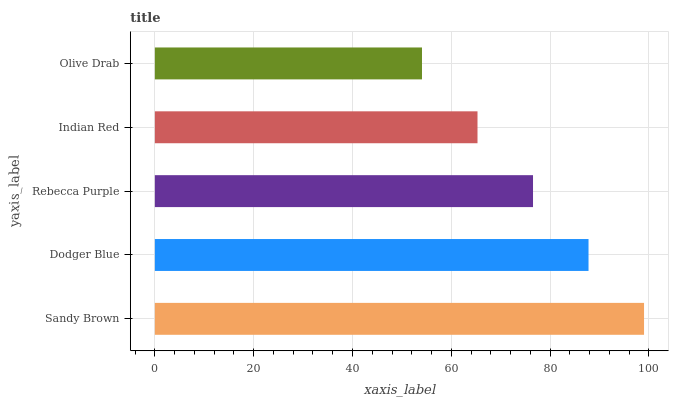Is Olive Drab the minimum?
Answer yes or no. Yes. Is Sandy Brown the maximum?
Answer yes or no. Yes. Is Dodger Blue the minimum?
Answer yes or no. No. Is Dodger Blue the maximum?
Answer yes or no. No. Is Sandy Brown greater than Dodger Blue?
Answer yes or no. Yes. Is Dodger Blue less than Sandy Brown?
Answer yes or no. Yes. Is Dodger Blue greater than Sandy Brown?
Answer yes or no. No. Is Sandy Brown less than Dodger Blue?
Answer yes or no. No. Is Rebecca Purple the high median?
Answer yes or no. Yes. Is Rebecca Purple the low median?
Answer yes or no. Yes. Is Sandy Brown the high median?
Answer yes or no. No. Is Sandy Brown the low median?
Answer yes or no. No. 